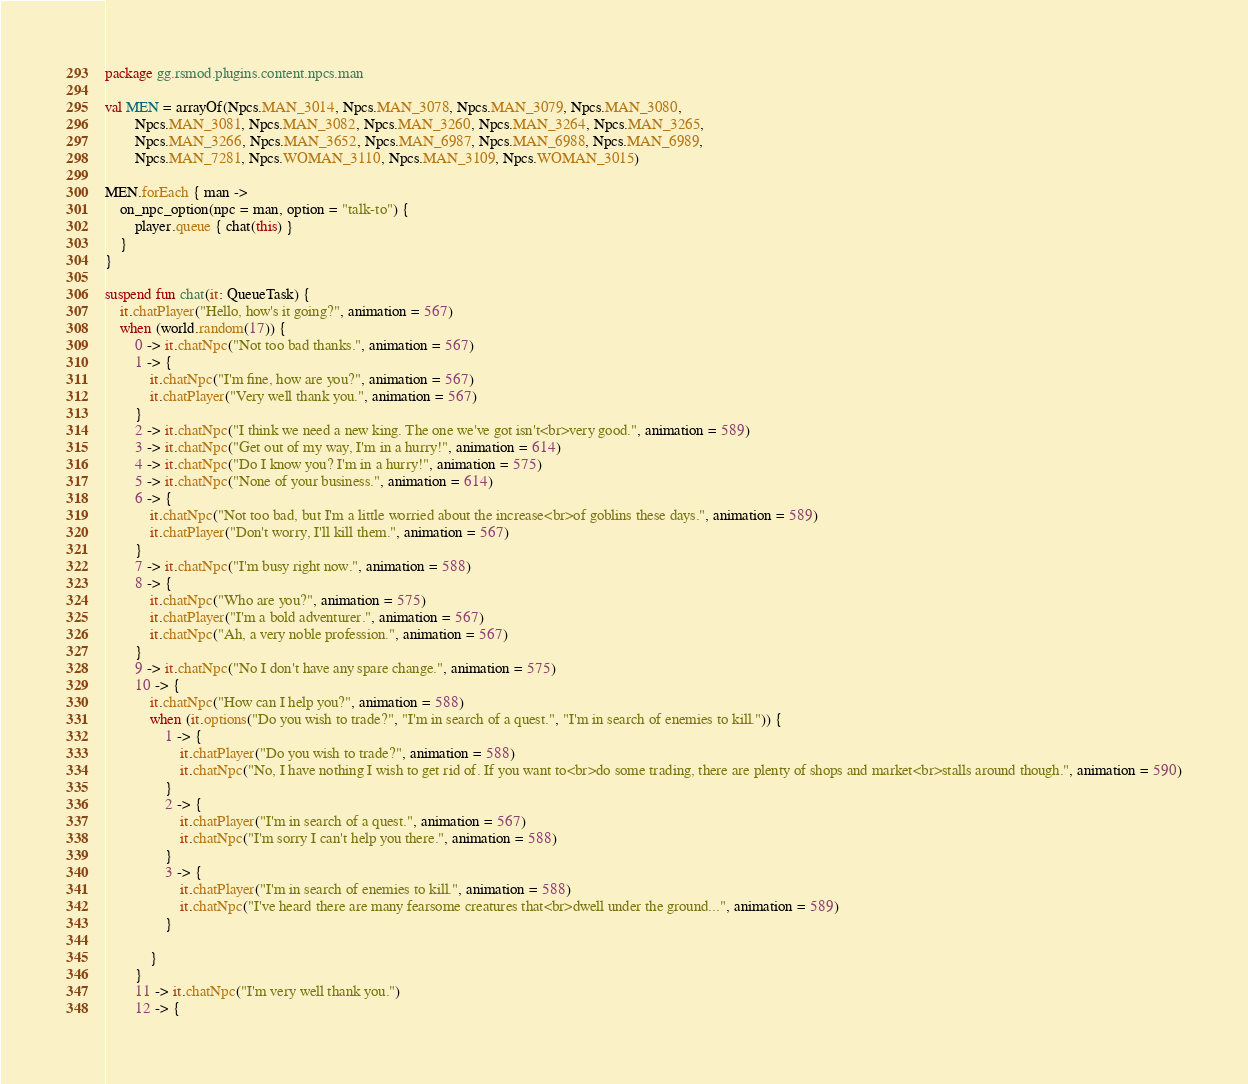Convert code to text. <code><loc_0><loc_0><loc_500><loc_500><_Kotlin_>package gg.rsmod.plugins.content.npcs.man

val MEN = arrayOf(Npcs.MAN_3014, Npcs.MAN_3078, Npcs.MAN_3079, Npcs.MAN_3080,
        Npcs.MAN_3081, Npcs.MAN_3082, Npcs.MAN_3260, Npcs.MAN_3264, Npcs.MAN_3265,
        Npcs.MAN_3266, Npcs.MAN_3652, Npcs.MAN_6987, Npcs.MAN_6988, Npcs.MAN_6989,
        Npcs.MAN_7281, Npcs.WOMAN_3110, Npcs.MAN_3109, Npcs.WOMAN_3015)

MEN.forEach { man ->
    on_npc_option(npc = man, option = "talk-to") {
        player.queue { chat(this) }
    }
}

suspend fun chat(it: QueueTask) {
    it.chatPlayer("Hello, how's it going?", animation = 567)
    when (world.random(17)) {
        0 -> it.chatNpc("Not too bad thanks.", animation = 567)
        1 -> {
            it.chatNpc("I'm fine, how are you?", animation = 567)
            it.chatPlayer("Very well thank you.", animation = 567)
        }
        2 -> it.chatNpc("I think we need a new king. The one we've got isn't<br>very good.", animation = 589)
        3 -> it.chatNpc("Get out of my way, I'm in a hurry!", animation = 614)
        4 -> it.chatNpc("Do I know you? I'm in a hurry!", animation = 575)
        5 -> it.chatNpc("None of your business.", animation = 614)
        6 -> {
            it.chatNpc("Not too bad, but I'm a little worried about the increase<br>of goblins these days.", animation = 589)
            it.chatPlayer("Don't worry, I'll kill them.", animation = 567)
        }
        7 -> it.chatNpc("I'm busy right now.", animation = 588)
        8 -> {
            it.chatNpc("Who are you?", animation = 575)
            it.chatPlayer("I'm a bold adventurer.", animation = 567)
            it.chatNpc("Ah, a very noble profession.", animation = 567)
        }
        9 -> it.chatNpc("No I don't have any spare change.", animation = 575)
        10 -> {
            it.chatNpc("How can I help you?", animation = 588)
            when (it.options("Do you wish to trade?", "I'm in search of a quest.", "I'm in search of enemies to kill.")) {
                1 -> {
                    it.chatPlayer("Do you wish to trade?", animation = 588)
                    it.chatNpc("No, I have nothing I wish to get rid of. If you want to<br>do some trading, there are plenty of shops and market<br>stalls around though.", animation = 590)
                }
                2 -> {
                    it.chatPlayer("I'm in search of a quest.", animation = 567)
                    it.chatNpc("I'm sorry I can't help you there.", animation = 588)
                }
                3 -> {
                    it.chatPlayer("I'm in search of enemies to kill.", animation = 588)
                    it.chatNpc("I've heard there are many fearsome creatures that<br>dwell under the ground...", animation = 589)
                }

            }
        }
        11 -> it.chatNpc("I'm very well thank you.")
        12 -> {</code> 